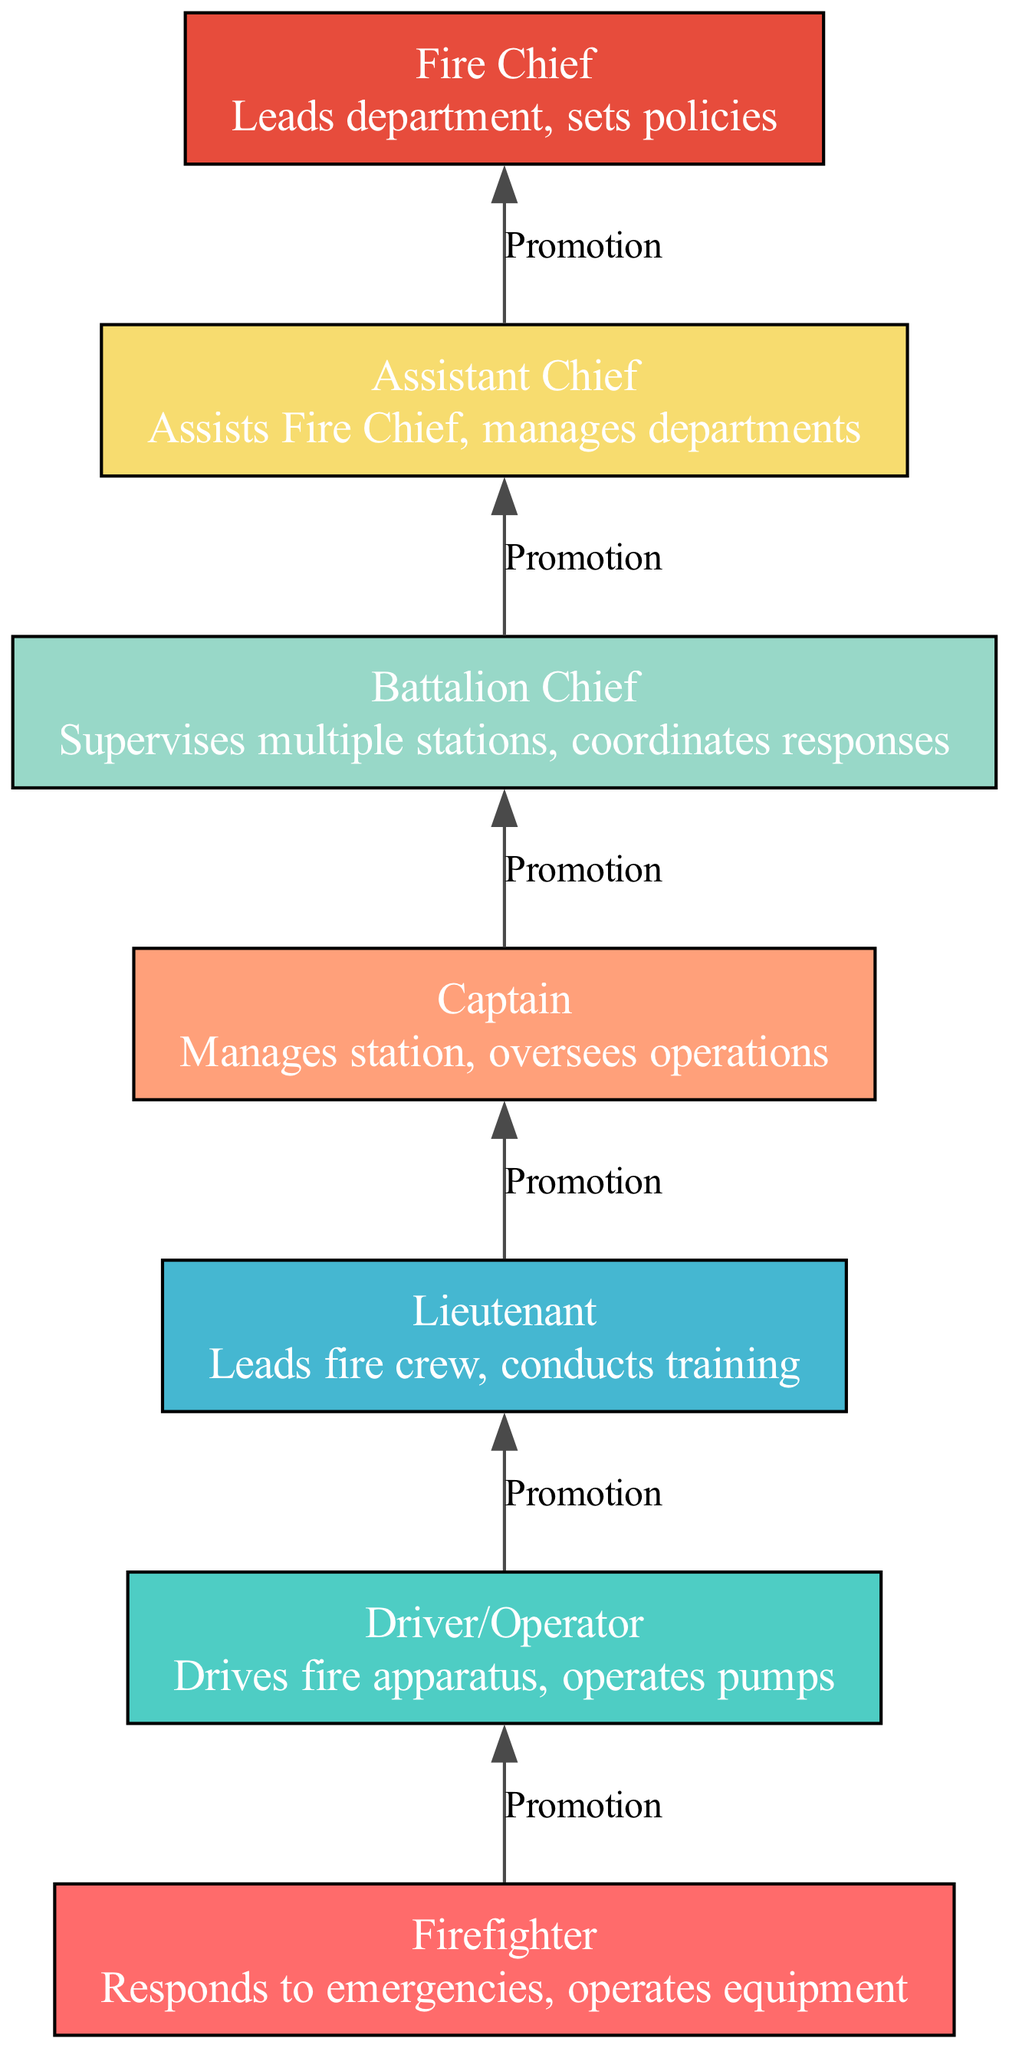What is the bottom node in the hierarchy? The bottom node in the hierarchy is the Firefighter, which is the first role in the ladder of promotions leading up to the Fire Chief.
Answer: Firefighter How many total nodes are in the hierarchy? There are seven nodes in the hierarchy, each representing different roles within the fire department.
Answer: Seven What role comes after Driver/Operator? The role that comes after Driver/Operator is Lieutenant, as indicated by a promotion relationship directed upwards.
Answer: Lieutenant Which role is responsible for managing the station? The Captain is responsible for managing the station and overseeing operations, according to the diagram's descriptions.
Answer: Captain What is the relationship between Battalion Chief and Assistant Chief? The relationship between Battalion Chief and Assistant Chief is a promotion, showing that the Battalion Chief is one step below the Assistant Chief in the hierarchy.
Answer: Promotion If a firefighter is promoted, what is the next possible position they can achieve? The next possible position after being promoted from Firefighter is Driver/Operator, indicating the first step in their progression.
Answer: Driver/Operator How many promotions are represented in the diagram? There are six promotions represented in the diagram, connecting each role to the next higher position in the hierarchy.
Answer: Six What does the Fire Chief lead? The Fire Chief leads the department and sets policies, as specified in their role description within the hierarchy.
Answer: Department What color represents the Lieutenant node? The Lieutenant node is represented in a specific color that follows the color scheme established for each role, matching the palette specified in the diagram generation code.
Answer: Fourth color 